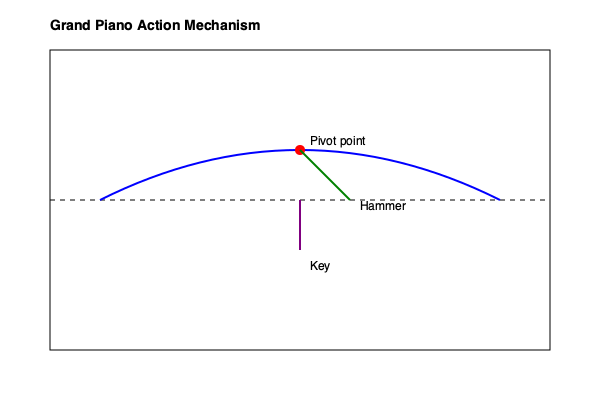In the context of a grand piano's action mechanism, explain how the principle of mechanical advantage is applied to amplify the pianist's finger movement, and calculate the approximate velocity ratio between the key and the hammer at the point of string impact. Assume the following measurements: key length from front to capstan: 40 cm, distance from key pivot to capstan: 35 cm, and effective hammer shank length: 10 cm. To understand how mechanical advantage is applied in a grand piano's action and calculate the velocity ratio, let's break it down step-by-step:

1. Mechanical Advantage in Piano Action:
   The piano action uses a system of levers to amplify the pianist's finger movement. The key acts as a first-class lever, with the fulcrum (pivot point) near the back of the key.

2. Key as a Lever:
   - Total key length: 40 cm
   - Distance from pivot to capstan (effort arm): 35 cm
   - Distance from pivot to front of key (resistance arm): 5 cm (40 cm - 35 cm)

3. Mechanical Advantage of the Key:
   $MA_{key} = \frac{\text{effort arm}}{\text{resistance arm}} = \frac{35 \text{ cm}}{5 \text{ cm}} = 7$

4. Hammer Movement:
   The hammer shank is connected to the action mechanism, which further amplifies the movement. The effective hammer shank length is 10 cm.

5. Velocity Ratio Calculation:
   The velocity ratio (VR) is the ratio of the output velocity (hammer) to the input velocity (key front).

   $VR = \frac{\text{key movement}}{\text{hammer movement}} \times \frac{\text{hammer shank length}}{\text{distance from key pivot to capstan}}$

   $VR = \frac{5 \text{ cm}}{35 \text{ cm}} \times \frac{10 \text{ cm}}{35 \text{ cm}} = \frac{50}{1225} \approx 0.0408$

6. Interpretation:
   This means that for every unit of distance the key moves, the hammer moves approximately 0.0408 units in the opposite direction. However, due to the longer lever arm, the hammer's velocity is much higher.

7. Velocity Amplification:
   The reciprocal of the velocity ratio gives us the velocity amplification:

   $\text{Velocity Amplification} = \frac{1}{VR} \approx \frac{1}{0.0408} \approx 24.5$

Therefore, the hammer's velocity at the point of string impact is approximately 24.5 times greater than the velocity of the key's front end.
Answer: Velocity ratio: ≈0.0408; Velocity amplification: ≈24.5 times 